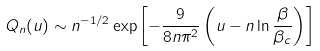<formula> <loc_0><loc_0><loc_500><loc_500>Q _ { n } ( u ) \sim n ^ { - 1 / 2 } \exp \left [ - \frac { 9 } { 8 n \pi ^ { 2 } } \left ( u - n \ln \frac { \beta } { \beta _ { c } } \right ) \right ]</formula> 